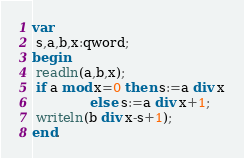Convert code to text. <code><loc_0><loc_0><loc_500><loc_500><_Pascal_>var
 s,a,b,x:qword;
begin
 readln(a,b,x);
 if a mod x=0 then s:=a div x
              else s:=a div x+1;
 writeln(b div x-s+1);
end.
</code> 